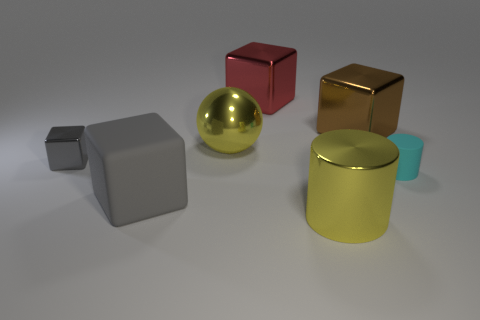What size is the metal block right of the yellow cylinder?
Offer a terse response. Large. Is there a cyan object that has the same material as the big gray cube?
Your answer should be very brief. Yes. There is a rubber object that is left of the ball; is its color the same as the ball?
Give a very brief answer. No. Are there the same number of big cubes that are in front of the big metal ball and tiny cylinders?
Your answer should be compact. Yes. Is there a large shiny block that has the same color as the small metal cube?
Make the answer very short. No. Do the cyan matte thing and the brown metallic block have the same size?
Ensure brevity in your answer.  No. There is a yellow thing behind the large cube that is on the left side of the metallic sphere; what is its size?
Keep it short and to the point. Large. There is a shiny cube that is both to the left of the large cylinder and behind the tiny gray thing; what size is it?
Your answer should be compact. Large. What number of shiny cubes have the same size as the cyan rubber object?
Give a very brief answer. 1. What number of shiny objects are big blue cubes or large spheres?
Your response must be concise. 1. 